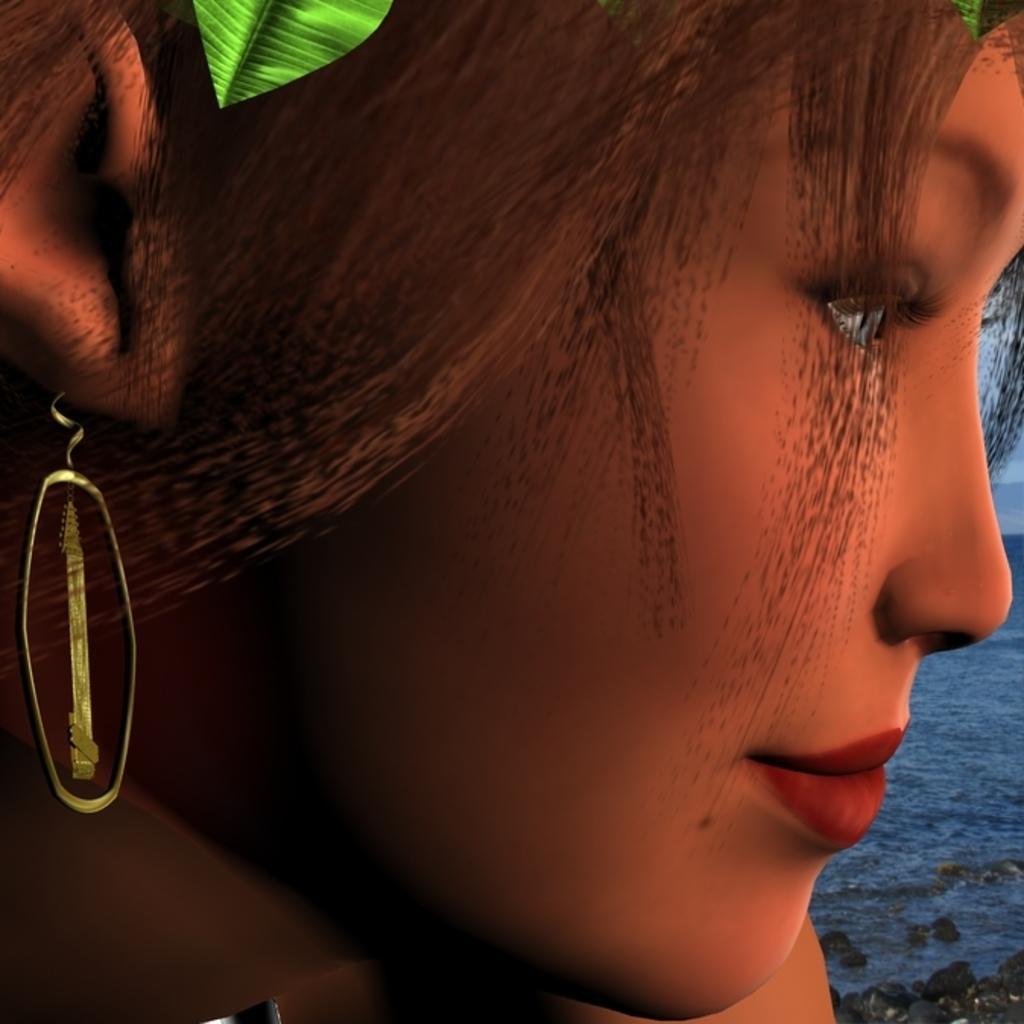How would you summarize this image in a sentence or two? This is an animation, in this image in the foreground there is one woman who is wearing an earring and on the right side of the image there is a river and at the top of the image there is one leaf. 